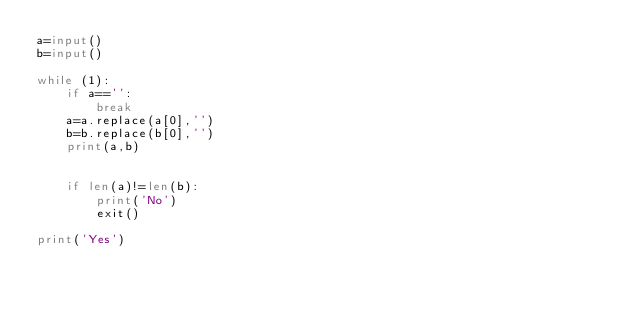Convert code to text. <code><loc_0><loc_0><loc_500><loc_500><_Python_>a=input()
b=input()

while (1):
    if a=='':
        break
    a=a.replace(a[0],'')
    b=b.replace(b[0],'')
    print(a,b)
    

    if len(a)!=len(b):
        print('No')
        exit()

print('Yes')
</code> 